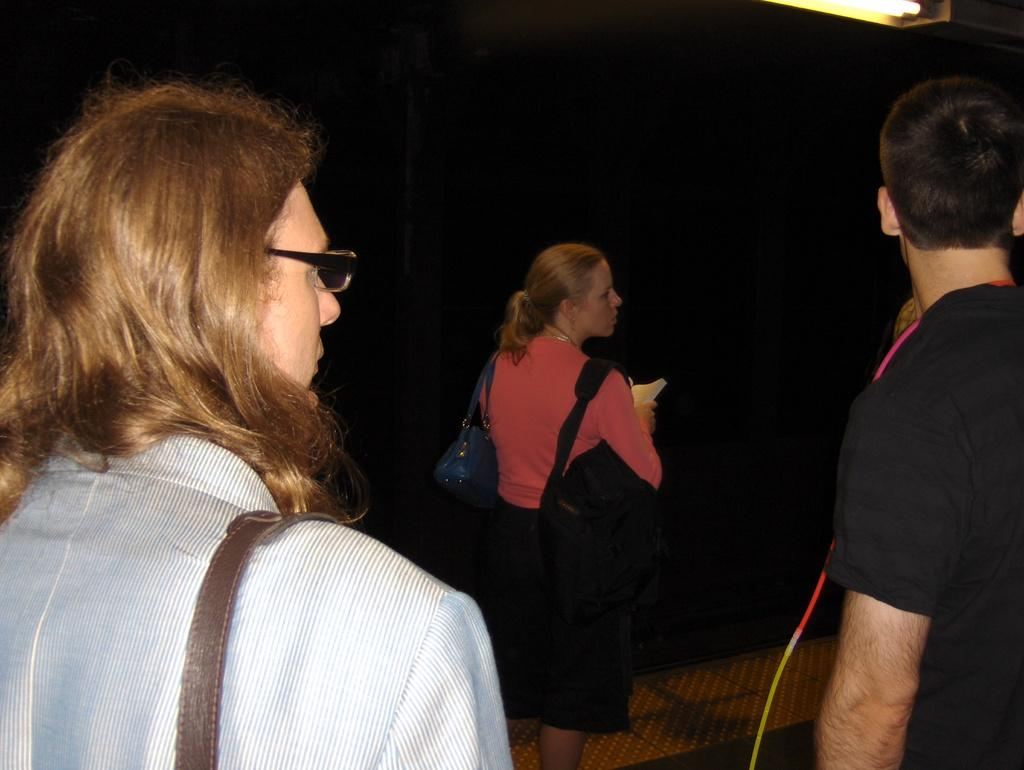How many people are present in the image? There are three people in the image: one man and two women. What are the women wearing that are visible in the image? The women are wearing bags in the image. What direction are the women looking in the image? The women are looking at the right side in the image. What is the color of the background in the image? The background of the image is black. What type of dress is the man wearing in the image? The facts do not mention a dress, and the man is not wearing a dress in the image. Can you see any steam coming from the women's bags in the image? There is no steam visible in the image, and the women's bags do not appear to be emitting steam. 